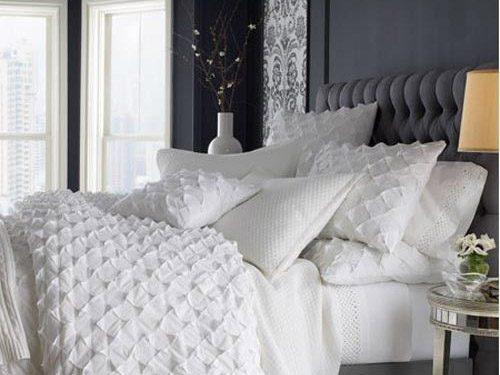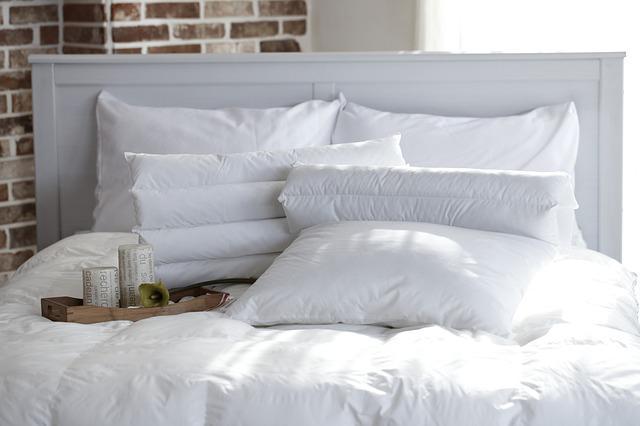The first image is the image on the left, the second image is the image on the right. Examine the images to the left and right. Is the description "There are flowers in a vase in one of the images." accurate? Answer yes or no. Yes. 